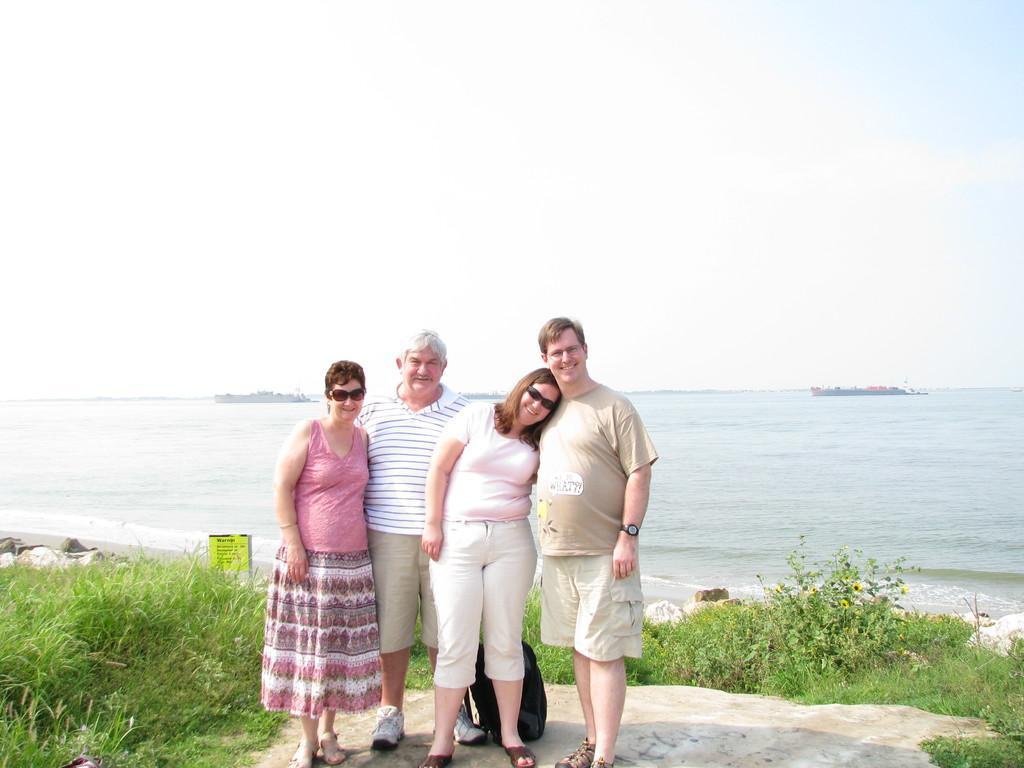Please provide a concise description of this image. In the image there are four people standing in the front and posing for the photo and they are standing on a rock surface around that there are many plants and grass and in the background there is a river. 